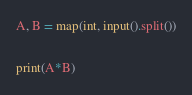Convert code to text. <code><loc_0><loc_0><loc_500><loc_500><_Python_>A, B = map(int, input().split())

print(A*B)</code> 